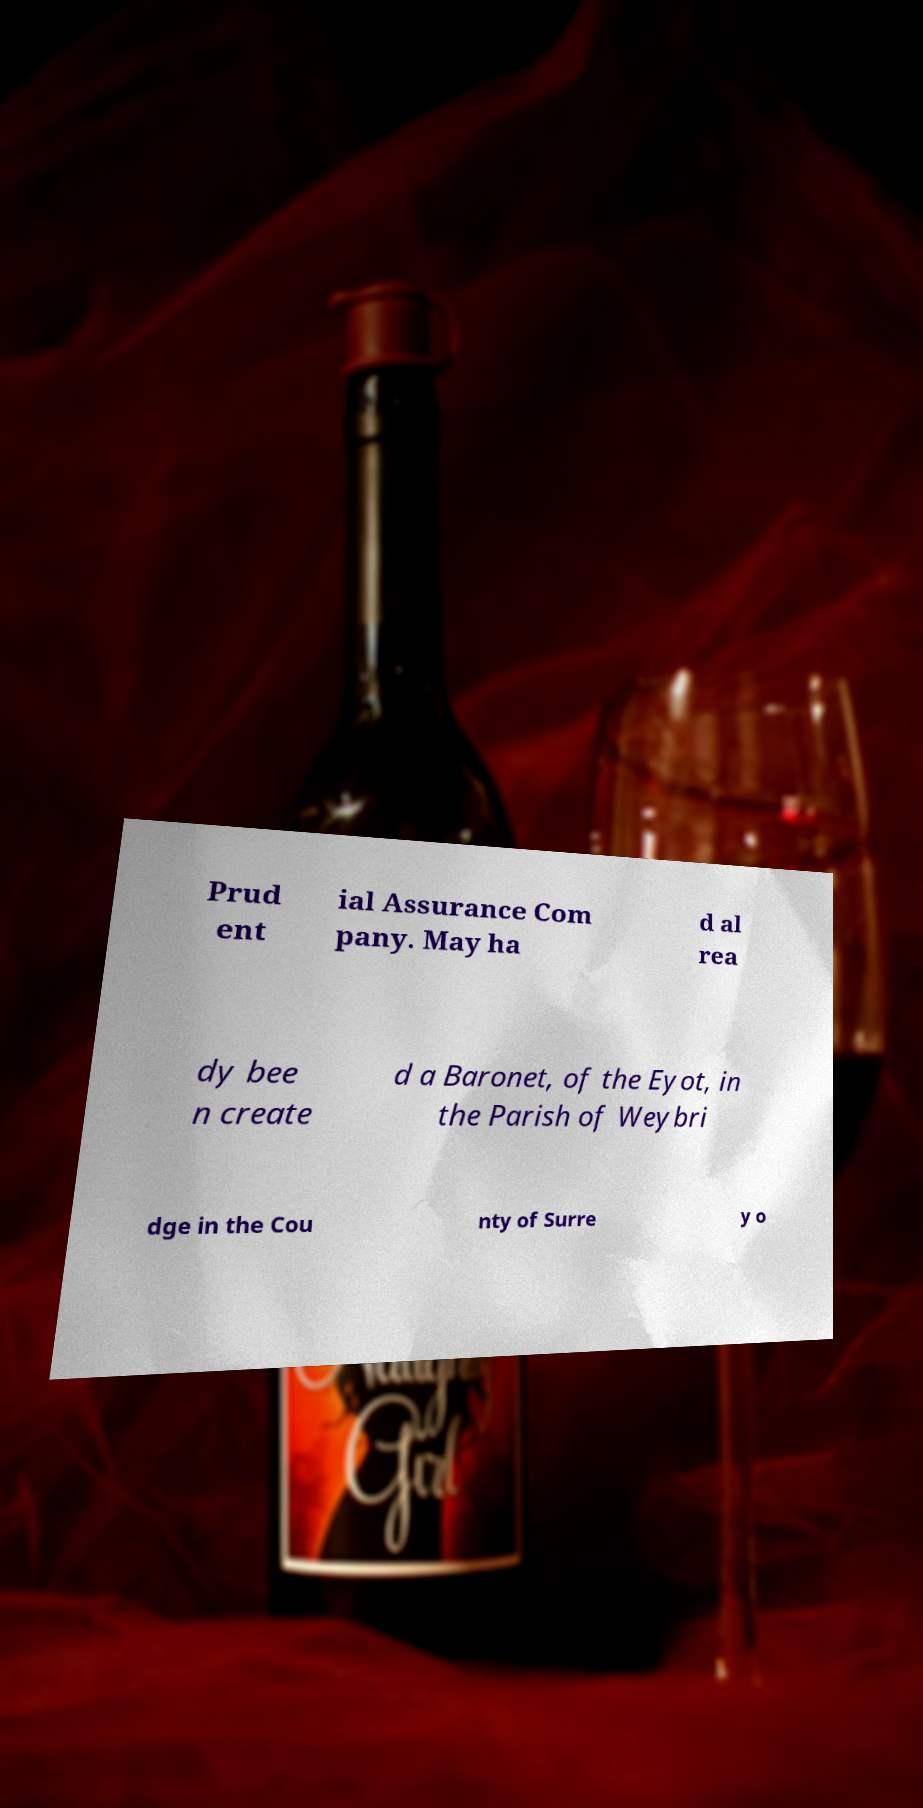Could you extract and type out the text from this image? Prud ent ial Assurance Com pany. May ha d al rea dy bee n create d a Baronet, of the Eyot, in the Parish of Weybri dge in the Cou nty of Surre y o 